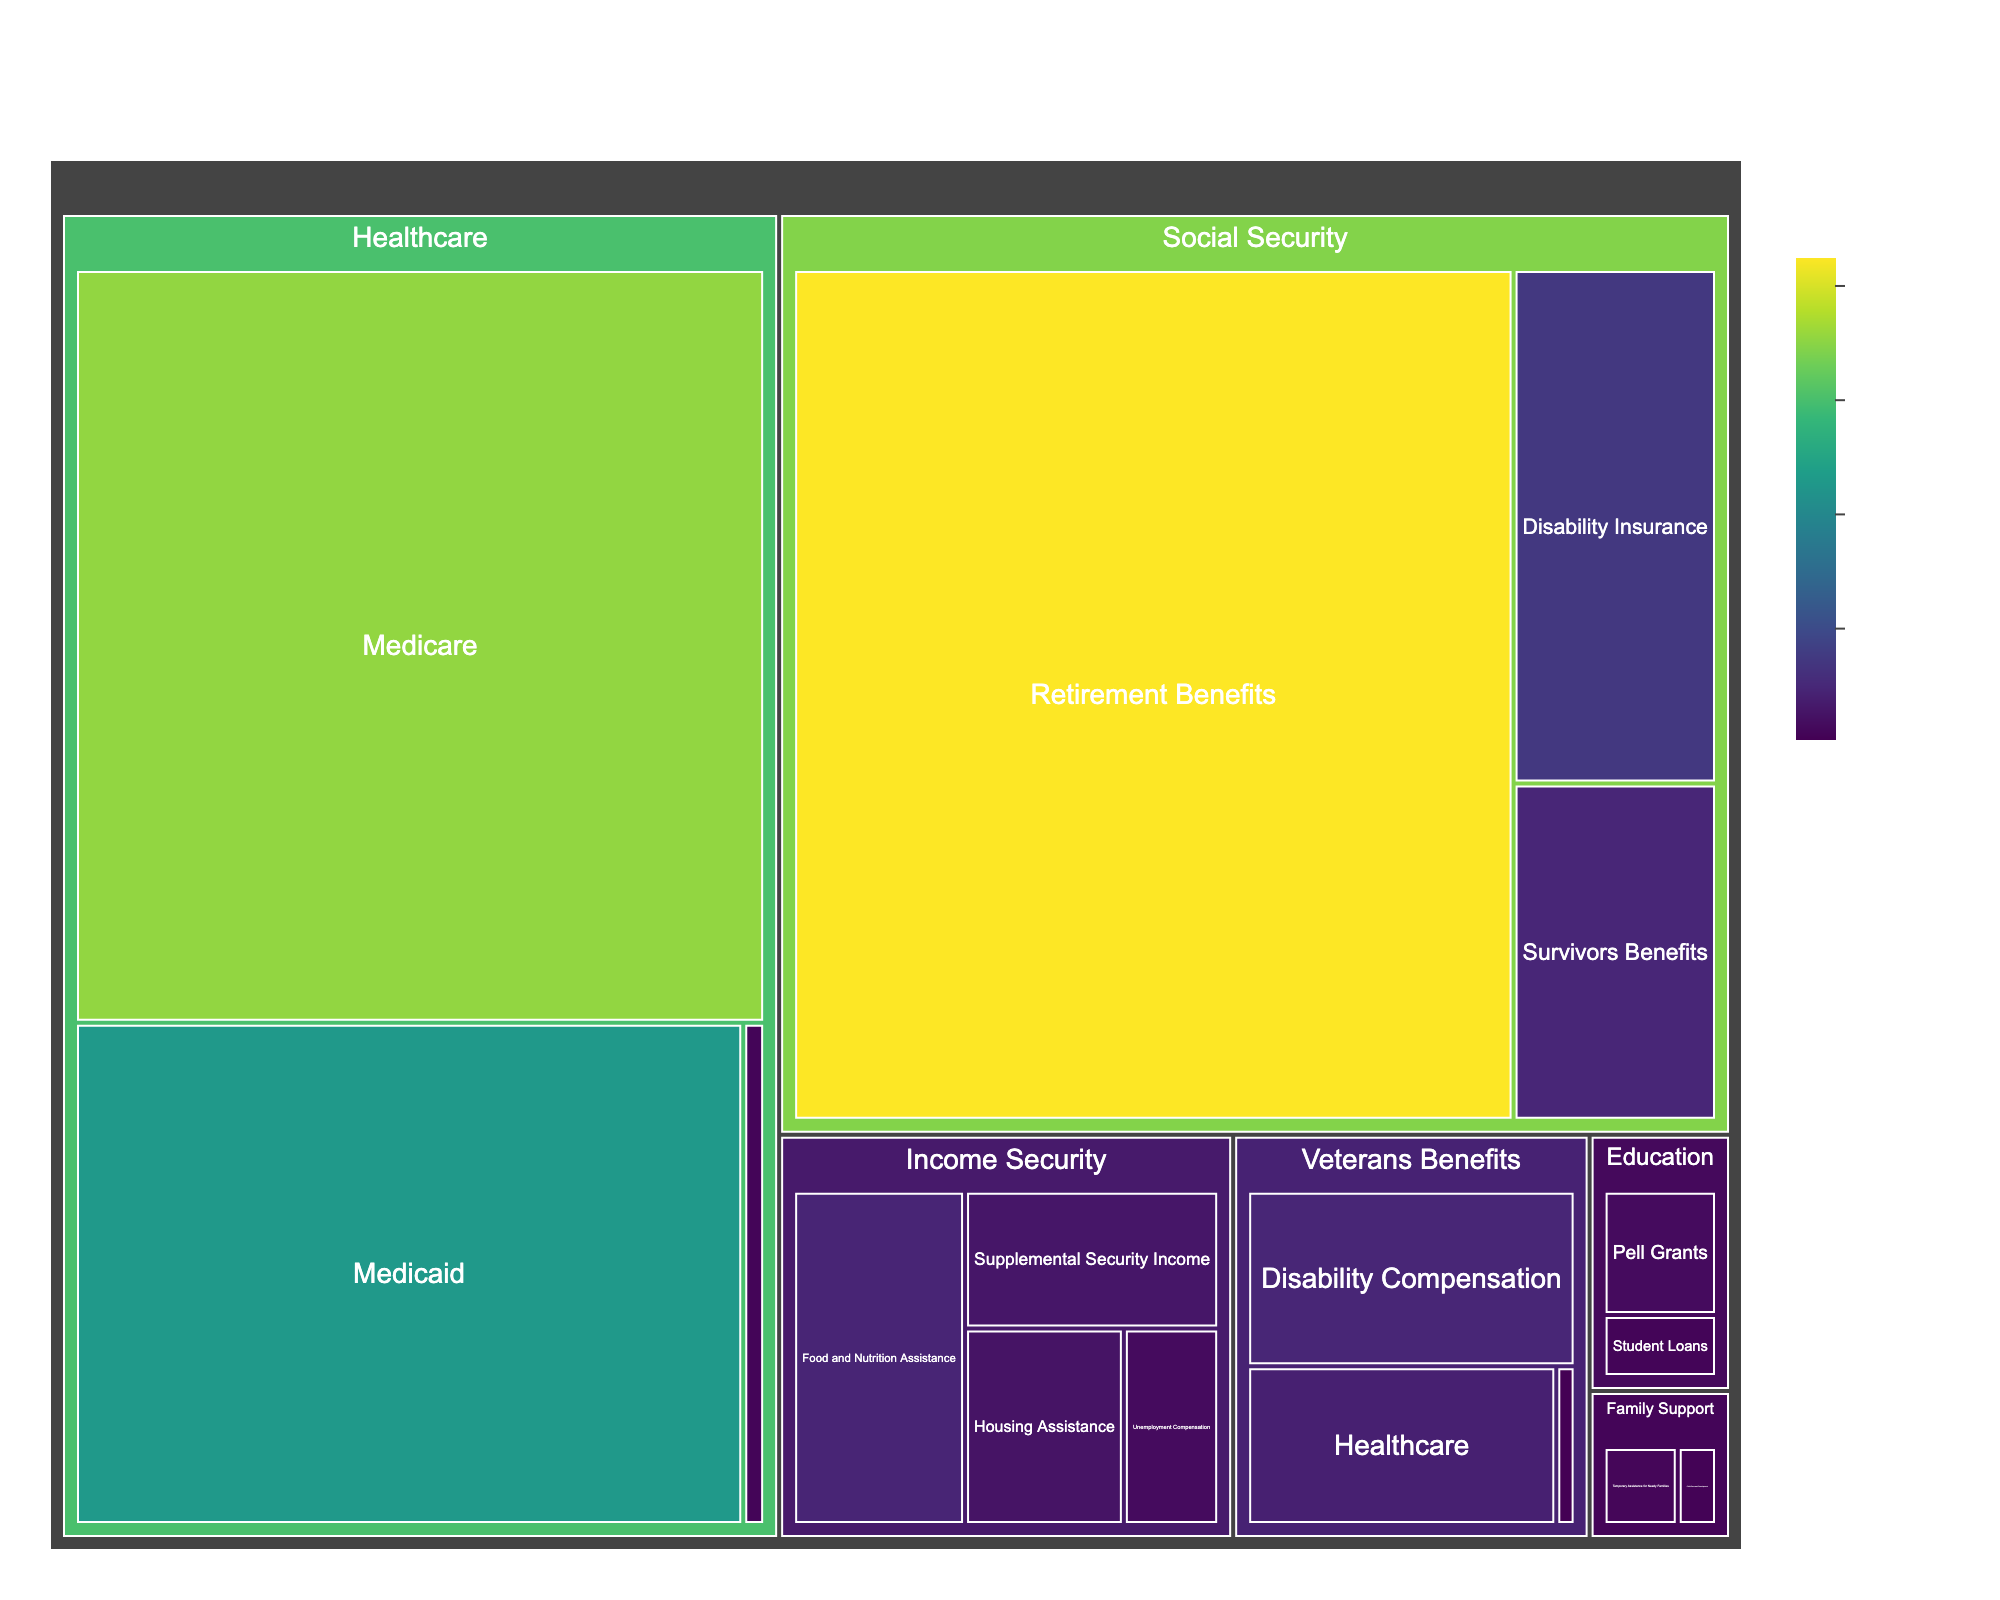What is the total expenditure on Social Security? Calculate the sum of all subcategories under Social Security: $850 + $145 + $95 = $1,090 billion
Answer: $1,090 billion Which subcategory under Healthcare has the highest expenditure? Among subcategories under Healthcare, Medicare is $710 billion, Medicaid is $458 billion, and CHIP is $15 billion. Medicare is the highest.
Answer: Medicare Is the expenditure on Veterans Benefits' Disability Compensation higher than that on Housing Assistance? Compare $94 billion (Veterans Benefits' Disability Compensation) with $50 billion (Housing Assistance). $94 billion is higher.
Answer: Yes What is the smallest expenditure in any subcategory? Identify the smallest number in all subcategories: $5 billion for Veterans Pensions.
Answer: $5 billion How does the expenditure on Medicaid compare to that on Social Security's Disability Insurance and Survivors Benefits combined? First, sum Disability Insurance and Survivors Benefits: $145 + $95 = $240 billion. Compare $240 billion to Medicaid's $458 billion. Medicaid has a higher expenditure.
Answer: Medicaid is higher What is the average expenditure across all subcategories in Income Security? Sum all subcategories in Income Security: $30 + $92 + $50 + $56 = $228 billion. Divide by 4 (number of subcategories): $228 / 4 = $57 billion
Answer: $57 billion How much more is spent on Medicare than on Unemployment Compensation? Subtract Unemployment Compensation's $30 billion from Medicare's $710 billion: $710 - $30 = $680 billion
Answer: $680 billion Among categories, which has the highest total expenditure? Sum expenditures for all main categories: Social Security: $1,090 billion, Healthcare: $1,183 billion, Income Security: $228 billion, Veterans Benefits: $179 billion, Education: $45 billion, Family Support: $26 billion. Healthcare has the highest total.
Answer: Healthcare Which subcategory under Education receives more funding? Compare Pell Grants ($30 billion) and Student Loans ($15 billion). Pell Grants receive more funding.
Answer: Pell Grants What is the combined expenditure on Family Support programs? Sum expenditures for Family Support subcategories: $17 + $9 = $26 billion
Answer: $26 billion 